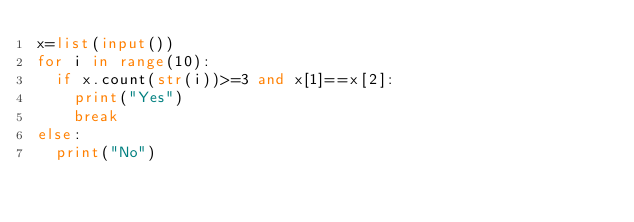Convert code to text. <code><loc_0><loc_0><loc_500><loc_500><_Python_>x=list(input())
for i in range(10):
  if x.count(str(i))>=3 and x[1]==x[2]: 
    print("Yes")
    break
else:
  print("No")
</code> 